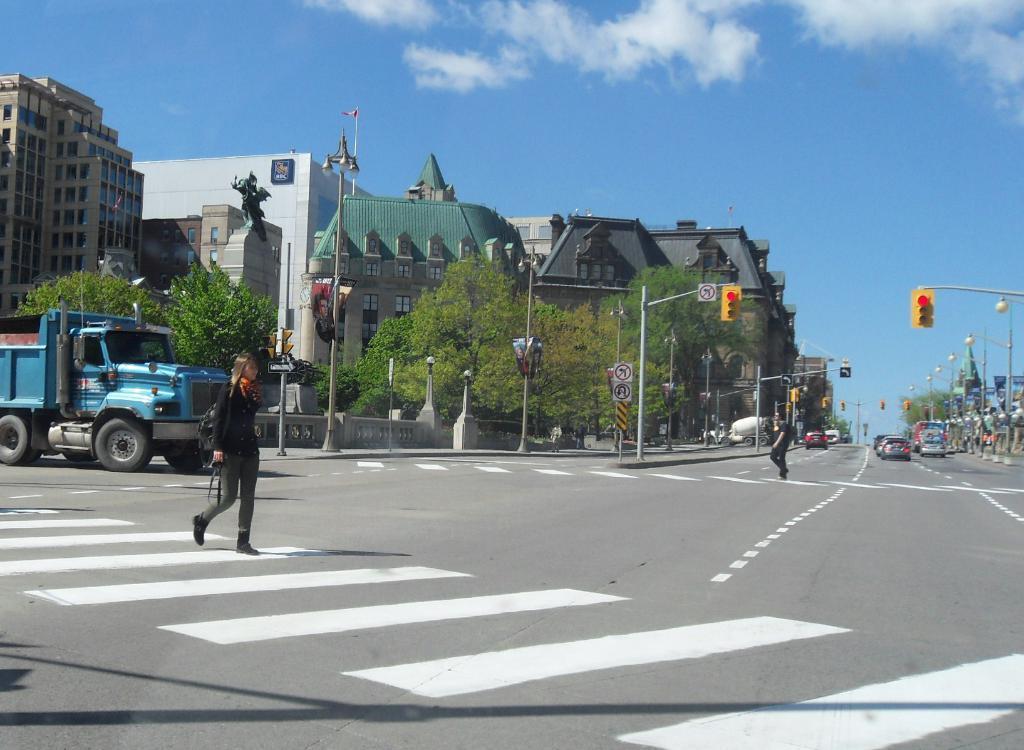Can you describe this image briefly? This image is taken outdoors. At the bottom of the image there is a road. At the top of the image there is the sky with clouds. In the background there are a few buildings with walls, windows, roofs and doors. There are a few trees and poles with street lights and signal lights. There are a few sign boards. On the left side of the image a truck is moving on the road and a woman is walking on the road. On the right side of the image a few cars are moving on the road. There are a few poles with street lights and there is a signal light. There is a building and there is a tree. A person is walking on the road. 